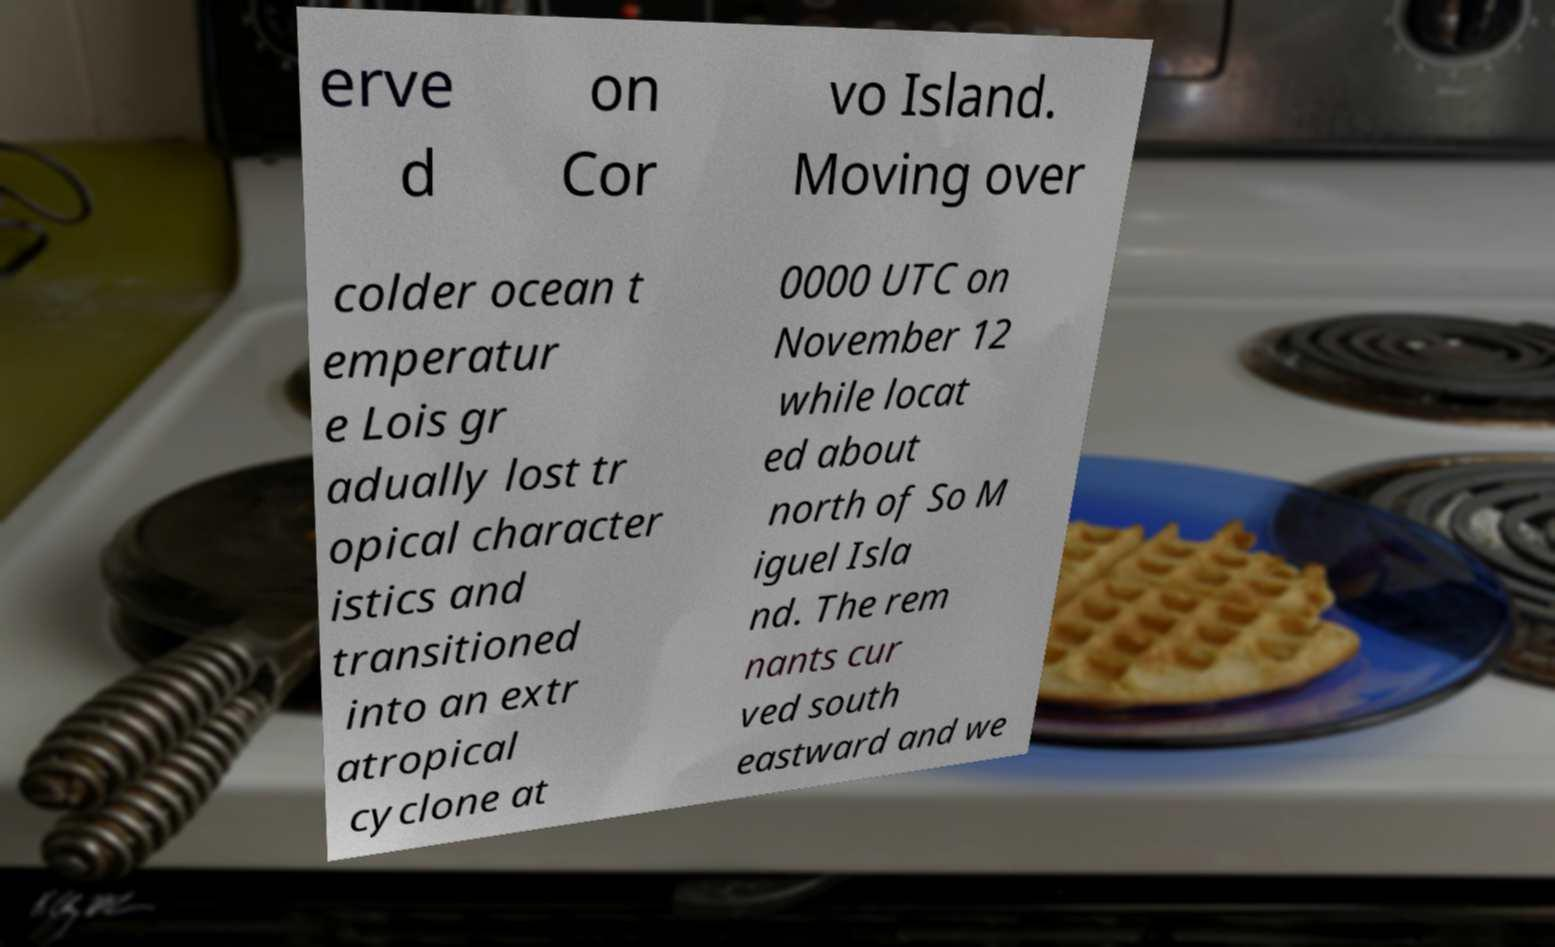Can you read and provide the text displayed in the image?This photo seems to have some interesting text. Can you extract and type it out for me? erve d on Cor vo Island. Moving over colder ocean t emperatur e Lois gr adually lost tr opical character istics and transitioned into an extr atropical cyclone at 0000 UTC on November 12 while locat ed about north of So M iguel Isla nd. The rem nants cur ved south eastward and we 